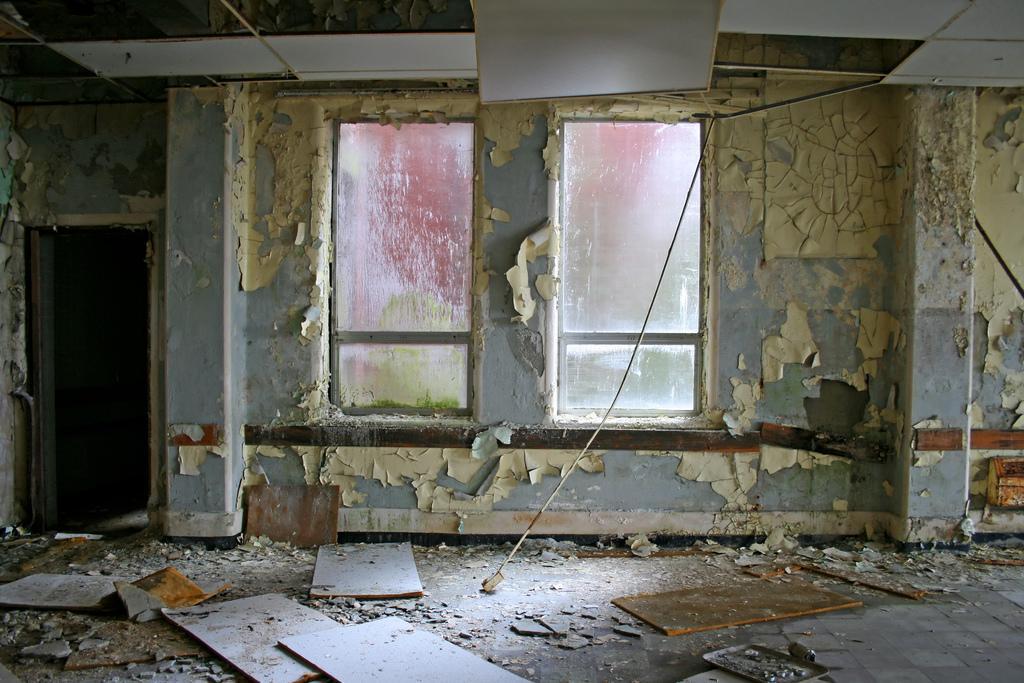In one or two sentences, can you explain what this image depicts? This image is taken inside the old building. In the center there is a wall and we can see windows and a door. At the bottom there are wooden blocks. 